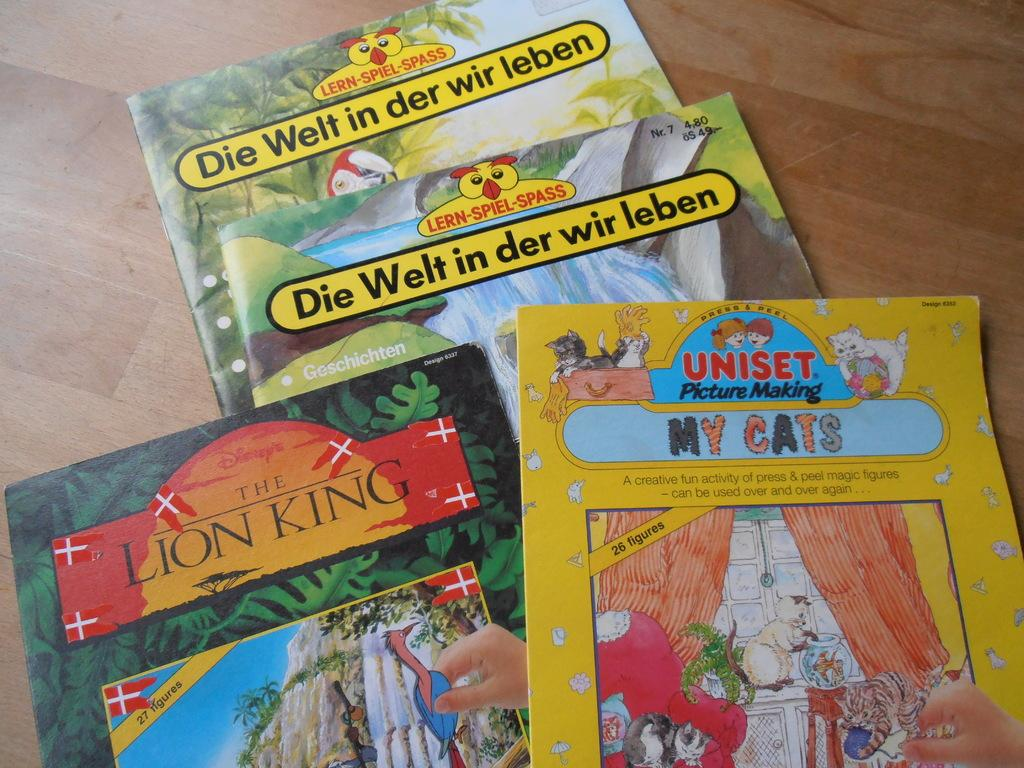<image>
Create a compact narrative representing the image presented. Four books like on a table and one of them is The Lion King. 